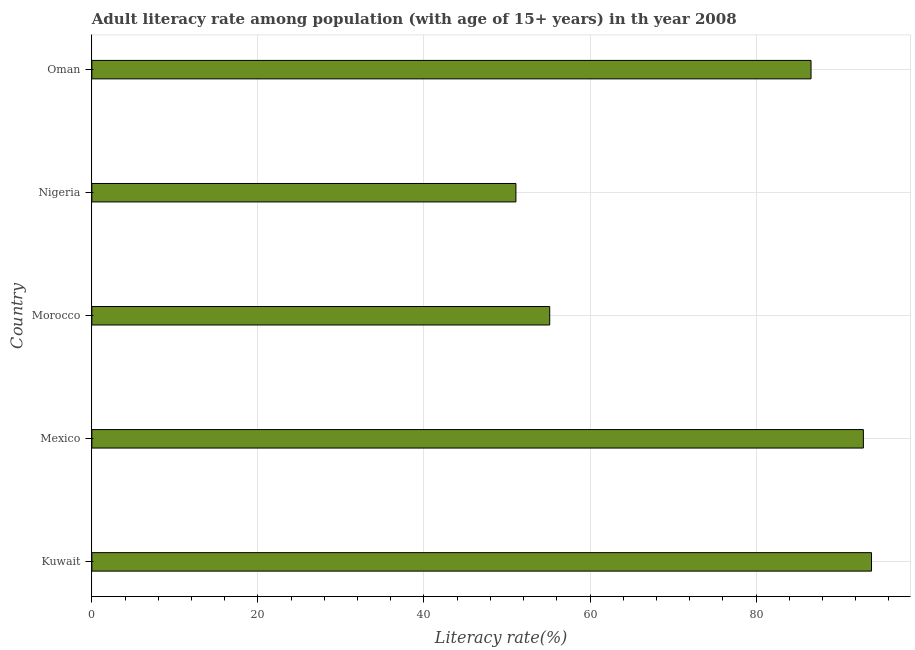Does the graph contain any zero values?
Make the answer very short. No. What is the title of the graph?
Make the answer very short. Adult literacy rate among population (with age of 15+ years) in th year 2008. What is the label or title of the X-axis?
Keep it short and to the point. Literacy rate(%). What is the adult literacy rate in Mexico?
Ensure brevity in your answer.  92.93. Across all countries, what is the maximum adult literacy rate?
Offer a terse response. 93.91. Across all countries, what is the minimum adult literacy rate?
Provide a succinct answer. 51.08. In which country was the adult literacy rate maximum?
Provide a succinct answer. Kuwait. In which country was the adult literacy rate minimum?
Ensure brevity in your answer.  Nigeria. What is the sum of the adult literacy rate?
Offer a terse response. 379.68. What is the difference between the adult literacy rate in Morocco and Oman?
Provide a succinct answer. -31.47. What is the average adult literacy rate per country?
Your answer should be very brief. 75.94. What is the median adult literacy rate?
Give a very brief answer. 86.62. What is the ratio of the adult literacy rate in Mexico to that in Oman?
Offer a very short reply. 1.07. Is the difference between the adult literacy rate in Morocco and Nigeria greater than the difference between any two countries?
Keep it short and to the point. No. What is the difference between the highest and the second highest adult literacy rate?
Keep it short and to the point. 0.98. What is the difference between the highest and the lowest adult literacy rate?
Provide a succinct answer. 42.83. In how many countries, is the adult literacy rate greater than the average adult literacy rate taken over all countries?
Ensure brevity in your answer.  3. How many bars are there?
Your answer should be compact. 5. Are the values on the major ticks of X-axis written in scientific E-notation?
Provide a short and direct response. No. What is the Literacy rate(%) of Kuwait?
Give a very brief answer. 93.91. What is the Literacy rate(%) of Mexico?
Ensure brevity in your answer.  92.93. What is the Literacy rate(%) in Morocco?
Your answer should be very brief. 55.15. What is the Literacy rate(%) in Nigeria?
Offer a terse response. 51.08. What is the Literacy rate(%) of Oman?
Keep it short and to the point. 86.62. What is the difference between the Literacy rate(%) in Kuwait and Mexico?
Offer a terse response. 0.98. What is the difference between the Literacy rate(%) in Kuwait and Morocco?
Provide a succinct answer. 38.76. What is the difference between the Literacy rate(%) in Kuwait and Nigeria?
Ensure brevity in your answer.  42.83. What is the difference between the Literacy rate(%) in Kuwait and Oman?
Offer a very short reply. 7.29. What is the difference between the Literacy rate(%) in Mexico and Morocco?
Provide a succinct answer. 37.78. What is the difference between the Literacy rate(%) in Mexico and Nigeria?
Your answer should be compact. 41.85. What is the difference between the Literacy rate(%) in Mexico and Oman?
Keep it short and to the point. 6.3. What is the difference between the Literacy rate(%) in Morocco and Nigeria?
Provide a succinct answer. 4.07. What is the difference between the Literacy rate(%) in Morocco and Oman?
Make the answer very short. -31.47. What is the difference between the Literacy rate(%) in Nigeria and Oman?
Your answer should be compact. -35.54. What is the ratio of the Literacy rate(%) in Kuwait to that in Mexico?
Make the answer very short. 1.01. What is the ratio of the Literacy rate(%) in Kuwait to that in Morocco?
Make the answer very short. 1.7. What is the ratio of the Literacy rate(%) in Kuwait to that in Nigeria?
Provide a succinct answer. 1.84. What is the ratio of the Literacy rate(%) in Kuwait to that in Oman?
Keep it short and to the point. 1.08. What is the ratio of the Literacy rate(%) in Mexico to that in Morocco?
Provide a short and direct response. 1.69. What is the ratio of the Literacy rate(%) in Mexico to that in Nigeria?
Provide a succinct answer. 1.82. What is the ratio of the Literacy rate(%) in Mexico to that in Oman?
Make the answer very short. 1.07. What is the ratio of the Literacy rate(%) in Morocco to that in Oman?
Your answer should be compact. 0.64. What is the ratio of the Literacy rate(%) in Nigeria to that in Oman?
Your answer should be very brief. 0.59. 